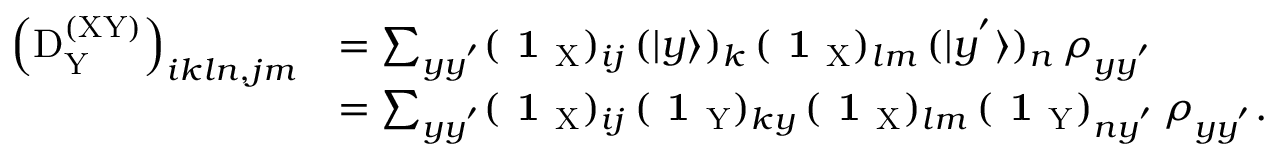Convert formula to latex. <formula><loc_0><loc_0><loc_500><loc_500>\begin{array} { r l } { \left ( D _ { \mathrm Y } ^ { ( X Y ) } \right ) _ { i k \ln , j m } } & { = \sum _ { y y ^ { ^ { \prime } } } ( 1 _ { X } ) _ { i j } \, ( | y \rangle ) _ { k } \, ( 1 _ { X } ) _ { l m } \, ( | y ^ { ^ { \prime } } \rangle ) _ { n } \, \rho _ { y y ^ { ^ { \prime } } } } \\ & { = \sum _ { y y ^ { ^ { \prime } } } ( 1 _ { X } ) _ { i j } \, ( 1 _ { Y } ) _ { k y } \, ( 1 _ { X } ) _ { l m } \, ( 1 _ { Y } ) _ { n y ^ { ^ { \prime } } } \, \rho _ { y y ^ { ^ { \prime } } } . } \end{array}</formula> 